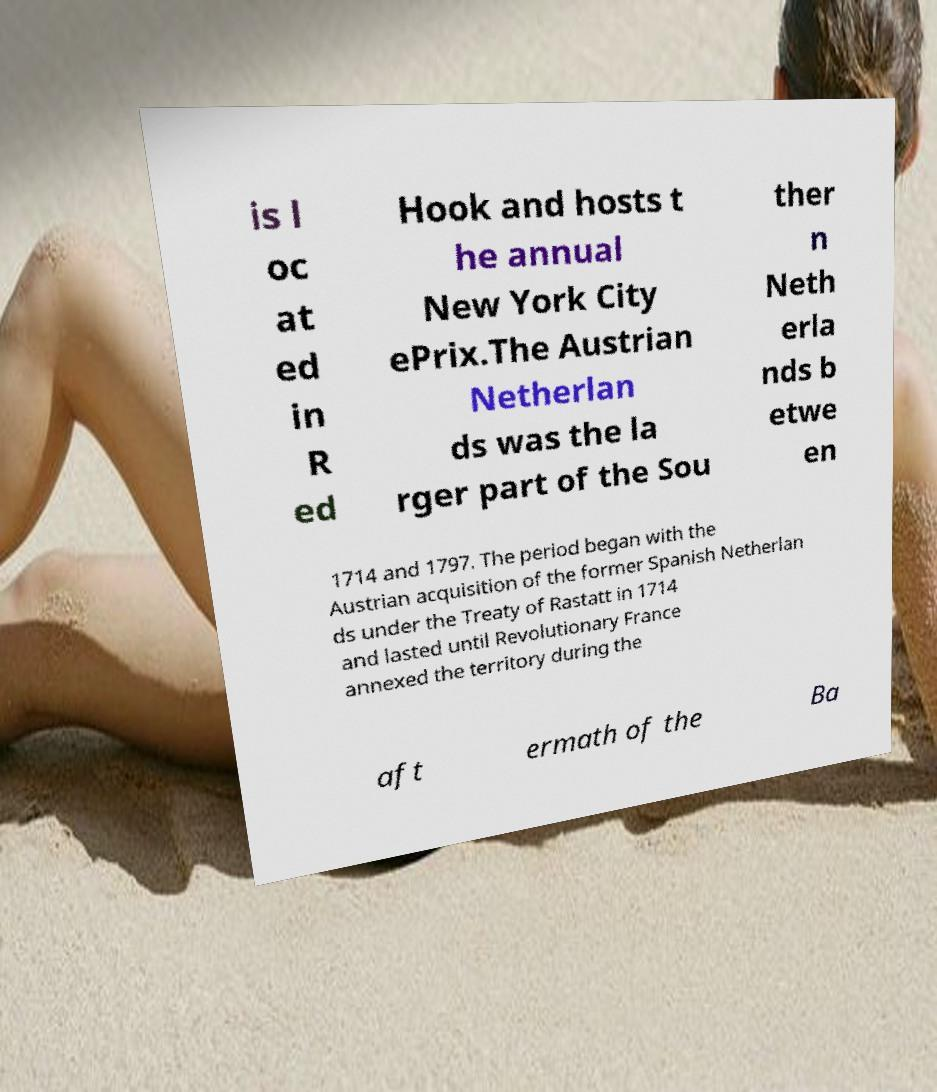There's text embedded in this image that I need extracted. Can you transcribe it verbatim? is l oc at ed in R ed Hook and hosts t he annual New York City ePrix.The Austrian Netherlan ds was the la rger part of the Sou ther n Neth erla nds b etwe en 1714 and 1797. The period began with the Austrian acquisition of the former Spanish Netherlan ds under the Treaty of Rastatt in 1714 and lasted until Revolutionary France annexed the territory during the aft ermath of the Ba 